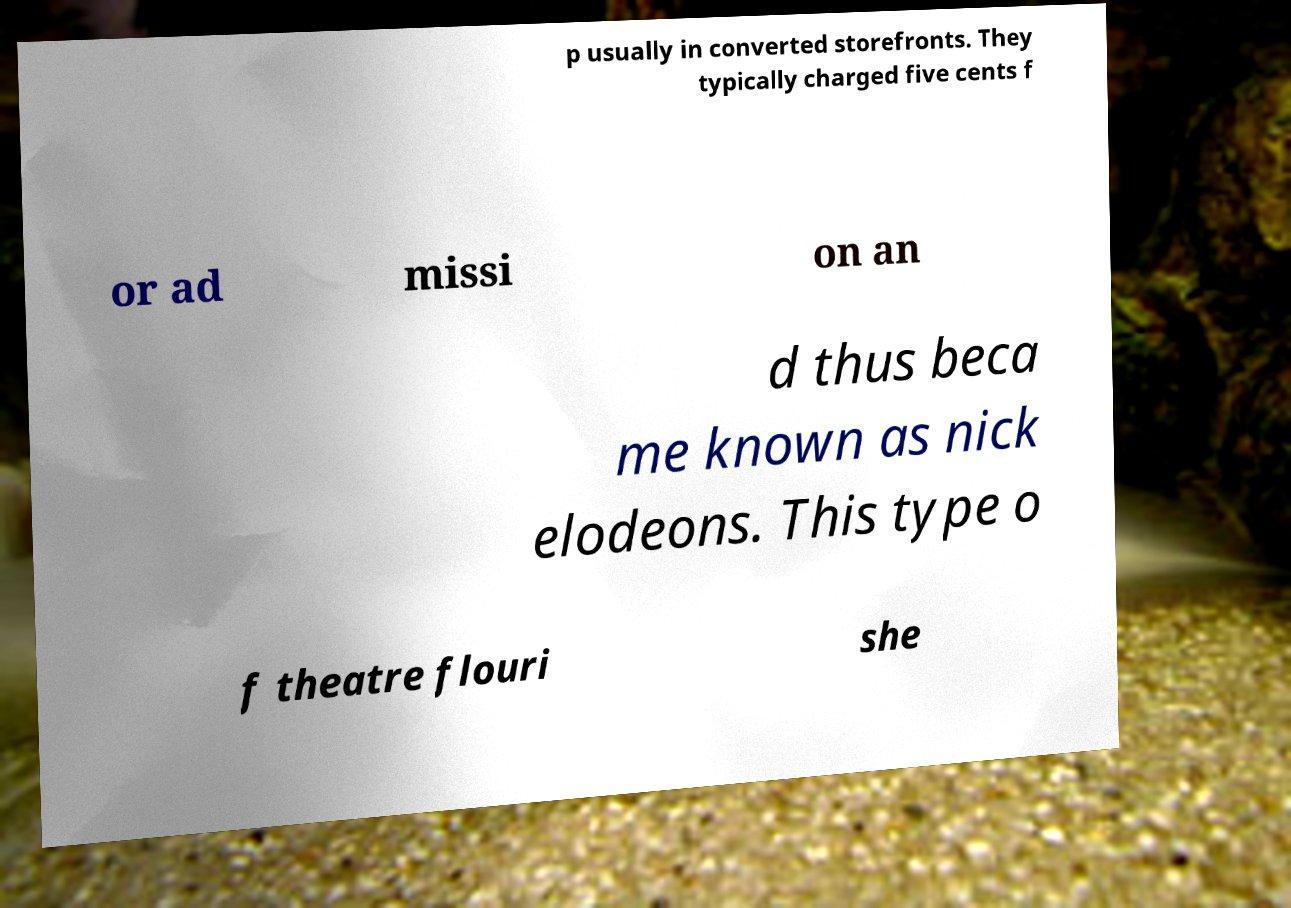What messages or text are displayed in this image? I need them in a readable, typed format. p usually in converted storefronts. They typically charged five cents f or ad missi on an d thus beca me known as nick elodeons. This type o f theatre flouri she 